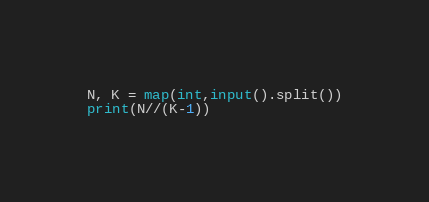<code> <loc_0><loc_0><loc_500><loc_500><_Python_>N, K = map(int,input().split())
print(N//(K-1))</code> 